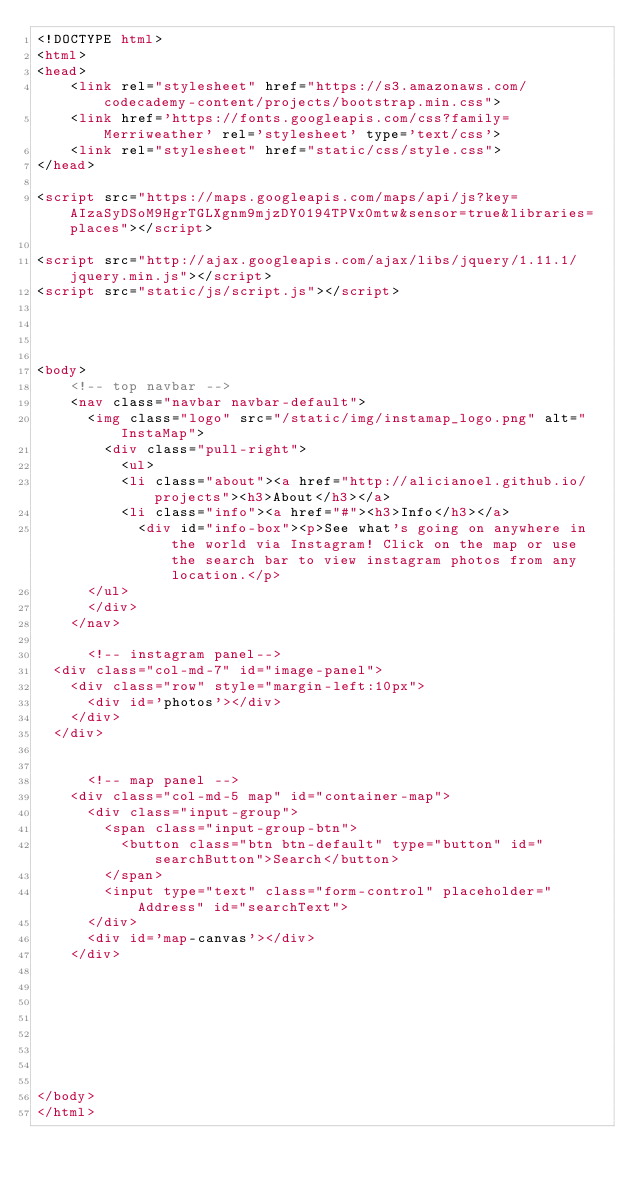<code> <loc_0><loc_0><loc_500><loc_500><_HTML_><!DOCTYPE html>
<html>
<head>
    <link rel="stylesheet" href="https://s3.amazonaws.com/codecademy-content/projects/bootstrap.min.css">
    <link href='https://fonts.googleapis.com/css?family=Merriweather' rel='stylesheet' type='text/css'>
    <link rel="stylesheet" href="static/css/style.css">
</head>

<script src="https://maps.googleapis.com/maps/api/js?key=AIzaSyDSoM9HgrTGLXgnm9mjzDY0194TPVx0mtw&sensor=true&libraries=places"></script>

<script src="http://ajax.googleapis.com/ajax/libs/jquery/1.11.1/jquery.min.js"></script>
<script src="static/js/script.js"></script>




<body>     
    <!-- top navbar -->
	<nav class="navbar navbar-default">
      <img class="logo" src="/static/img/instamap_logo.png" alt="InstaMap">
        <div class="pull-right">
          <ul>
          <li class="about"><a href="http://alicianoel.github.io/projects"><h3>About</h3></a>
          <li class="info"><a href="#"><h3>Info</h3></a>
            <div id="info-box"><p>See what's going on anywhere in the world via Instagram! Click on the map or use the search bar to view instagram photos from any location.</p>
      </ul>
      </div>
	</nav>

      <!-- instagram panel-->
  <div class="col-md-7" id="image-panel">
    <div class="row" style="margin-left:10px">
      <div id='photos'></div>
    </div>
  </div>


      <!-- map panel -->
	<div class="col-md-5 map" id="container-map">
	  <div class="input-group">
        <span class="input-group-btn">
          <button class="btn btn-default" type="button" id="searchButton">Search</button>
        </span>
        <input type="text" class="form-control" placeholder="Address" id="searchText">
      </div>
	  <div id='map-canvas'></div>
	</div>








</body>
</html></code> 